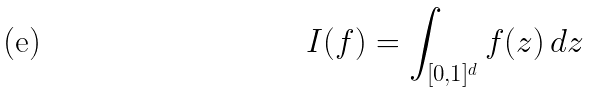<formula> <loc_0><loc_0><loc_500><loc_500>I ( f ) = \int _ { [ 0 , 1 ] ^ { d } } f ( z ) \, d z</formula> 